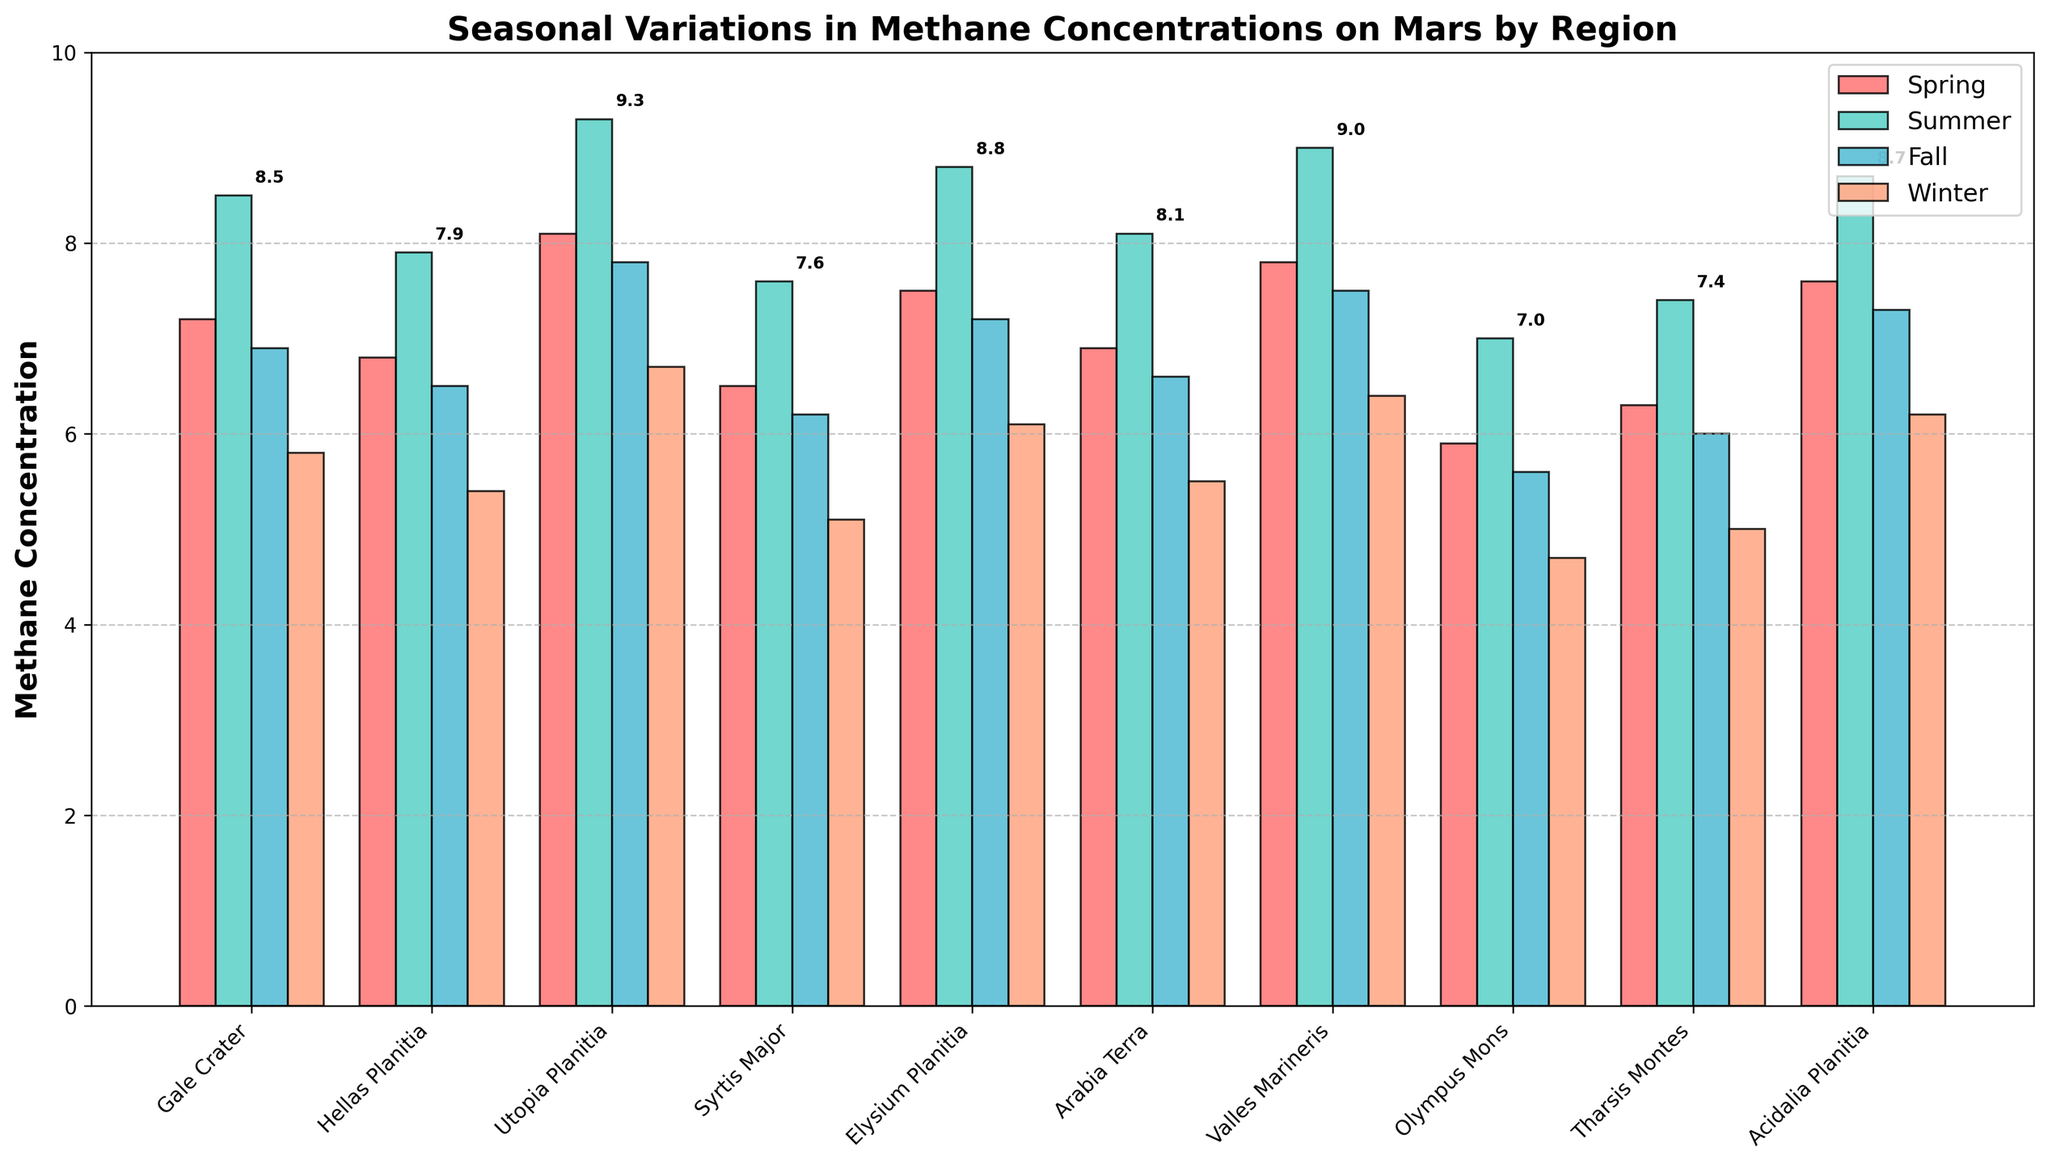Which region has the highest methane concentration in Summer? Look at the bar heights for the Summer season and identify the tallest one, which occurs in Utopia Planitia.
Answer: Utopia Planitia Which season shows the lowest methane concentration in Olympus Mons? Check the bar corresponding to each season for Olympus Mons and identify the shortest one, which is in Winter.
Answer: Winter What is the average methane concentration in Gale Crater across all seasons? Sum the values of methane concentrations in Gale Crater (7.2 + 8.5 + 6.9 + 5.8) and then divide by the number of seasons (4). The calculation is (7.2 + 8.5 + 6.9 + 5.8) / 4 = 28.4 / 4.
Answer: 7.1 How does the methane concentration in Spring at Tharsis Montes compare to Winter in the same region? Compare the bar heights for Spring and Winter at Tharsis Montes. Spring shows a higher value at 6.3 compared to Winter's 5.0.
Answer: Higher Which two regions have the most similar methane concentrations in Fall? Look at the bar heights for the Fall season across regions and find the closest values; Elysium Planitia (7.2) and Acidalia Planitia (7.3) are closest.
Answer: Elysium Planitia and Acidalia Planitia What is the difference in methane concentration between Spring and Fall in Valles Marineris? Subtract the Fall concentration from the Spring concentration for Valles Marineris: 7.8 (Spring) - 7.5 (Fall) = 0.3.
Answer: 0.3 Which region has the least variation in methane concentration across all seasons? Calculate the difference between the highest and lowest concentrations for each region and find the minimum difference. Olympus Mons has the least variation: 7.0 - 4.7 = 2.3.
Answer: Olympus Mons What is the total methane concentration in Spring across all regions? Sum the Spring values for all regions: 7.2 + 6.8 + 8.1 + 6.5 + 7.5 + 6.9 + 7.8 + 5.9 + 6.3 + 7.6 = 70.6.
Answer: 70.6 How do the methane concentrations in Summer compare between Gale Crater and Arabia Terra? Compare the heights of the Summer bars for Gale Crater (8.5) and Arabia Terra (8.1). Gale Crater has a higher concentration.
Answer: Gale Crater If you combine the Winter concentrations of Hellas Planitia and Syrtis Major, what would be the total concentration? Add the Winter values for Hellas Planitia (5.4) and Syrtis Major (5.1): 5.4 + 5.1 = 10.5.
Answer: 10.5 